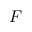Convert formula to latex. <formula><loc_0><loc_0><loc_500><loc_500>F</formula> 